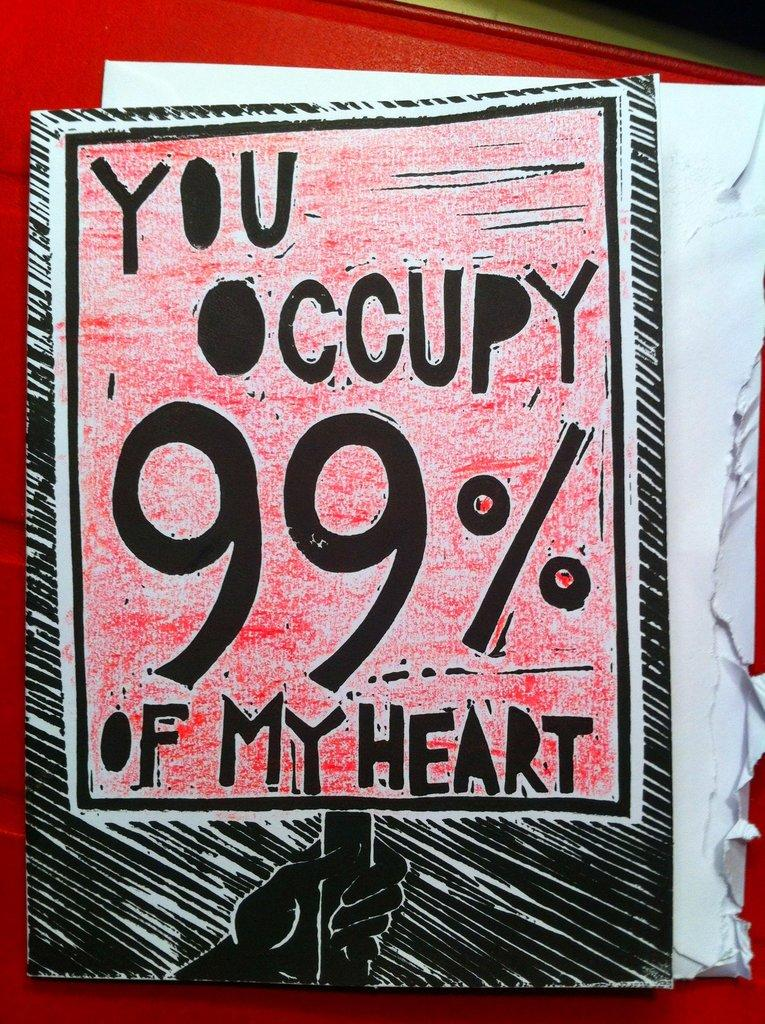<image>
Write a terse but informative summary of the picture. A sign taken from an envelope contains a play on the Occupy movement's slogan. 